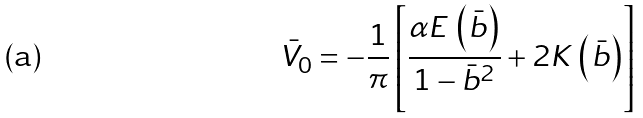<formula> <loc_0><loc_0><loc_500><loc_500>\bar { V } _ { 0 } = - \frac { 1 } { \pi } \left [ \frac { \alpha E \, \left ( \bar { b } \right ) } { 1 - \bar { b } ^ { 2 } } + 2 K \, \left ( \bar { b } \right ) \right ]</formula> 